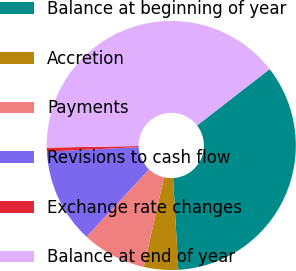Convert chart. <chart><loc_0><loc_0><loc_500><loc_500><pie_chart><fcel>Balance at beginning of year<fcel>Accretion<fcel>Payments<fcel>Revisions to cash flow<fcel>Exchange rate changes<fcel>Balance at end of year<nl><fcel>34.61%<fcel>4.44%<fcel>8.37%<fcel>12.29%<fcel>0.52%<fcel>39.77%<nl></chart> 